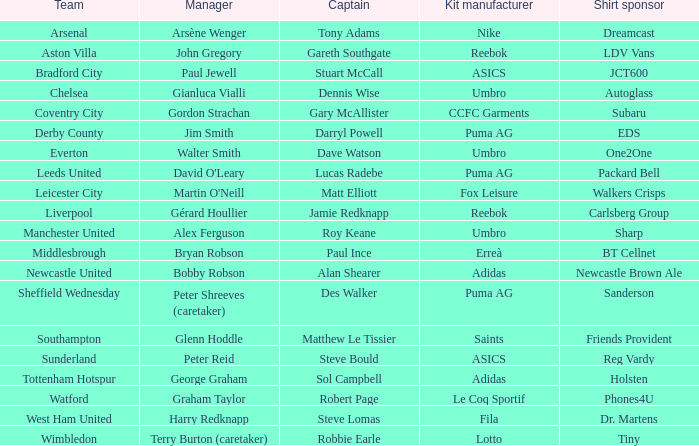Which team is managed by david o'leary? Leeds United. 